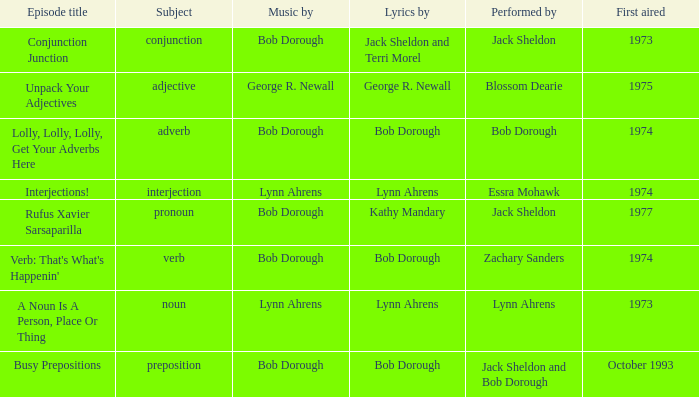In the context of interjection, how many participants are involved? 1.0. 